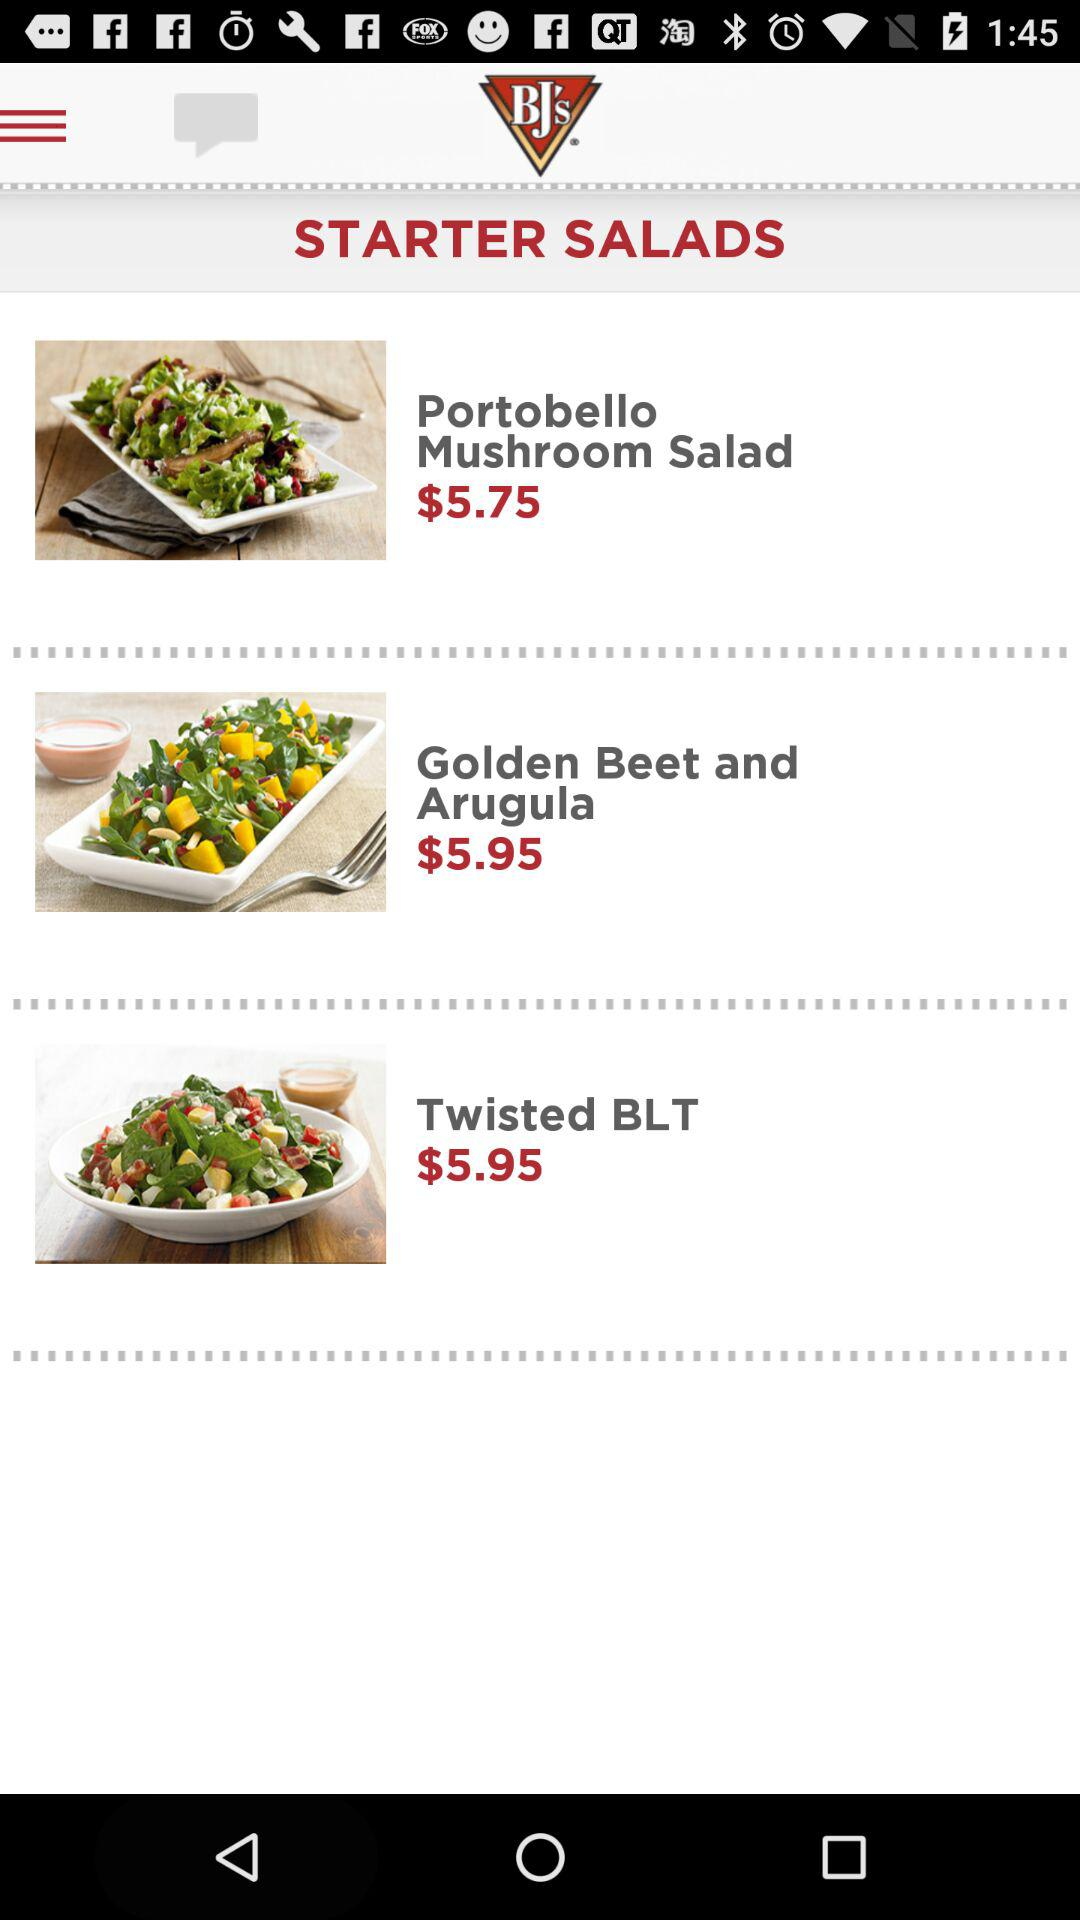How much more does the Twisted BLT cost than the Portobello Mushroom Salad?
Answer the question using a single word or phrase. $0.20 